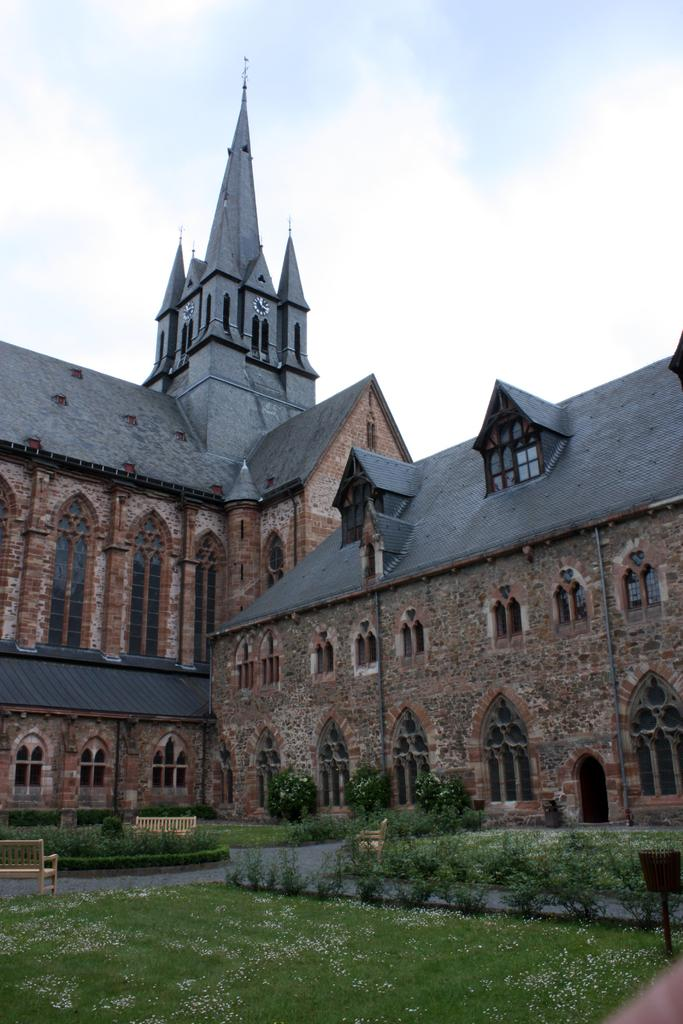What type of structure can be seen in the background of the image? There is a castle in the background of the image. What is located in front of the castle? There are trees and plants in front of the castle. What is visible in the sky in the image? The sky is visible in the image, and clouds are present. Can you touch the flower that is growing on the slope in the image? There is no flower or slope present in the image; it features a castle with trees and plants in front of it. 